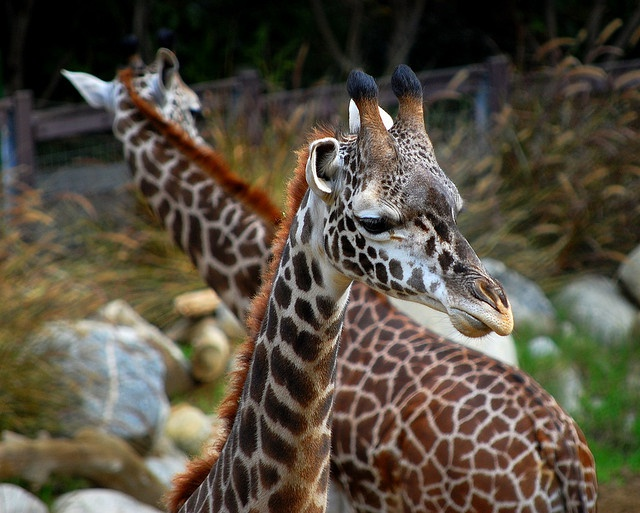Describe the objects in this image and their specific colors. I can see giraffe in black, gray, darkgray, and maroon tones and giraffe in black, maroon, gray, and darkgray tones in this image. 